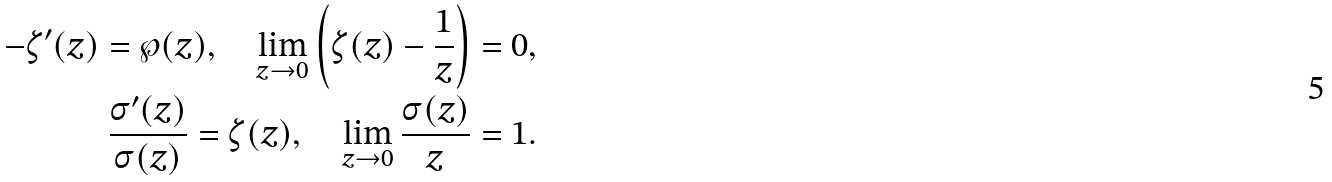Convert formula to latex. <formula><loc_0><loc_0><loc_500><loc_500>- \zeta ^ { \prime } ( z ) = \wp ( z ) , \quad \lim _ { z \rightarrow 0 } \left ( \zeta ( z ) - \frac { 1 } { z } \right ) = 0 , \\ \frac { \sigma ^ { \prime } ( z ) } { \sigma ( z ) } = \zeta ( z ) , \quad \lim _ { z \rightarrow 0 } \frac { \sigma ( z ) } { z } = 1 .</formula> 